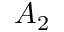<formula> <loc_0><loc_0><loc_500><loc_500>A _ { 2 }</formula> 